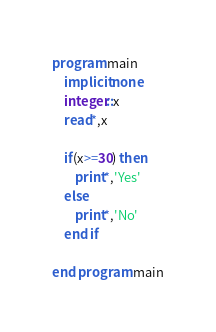Convert code to text. <code><loc_0><loc_0><loc_500><loc_500><_FORTRAN_>program main 
    implicit none
    integer::x
    read*,x

    if(x>=30) then
        print*,'Yes'
    else
        print*,'No'
    end if

end program main</code> 